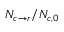<formula> <loc_0><loc_0><loc_500><loc_500>N _ { c \rightarrow r } / N _ { c , 0 }</formula> 